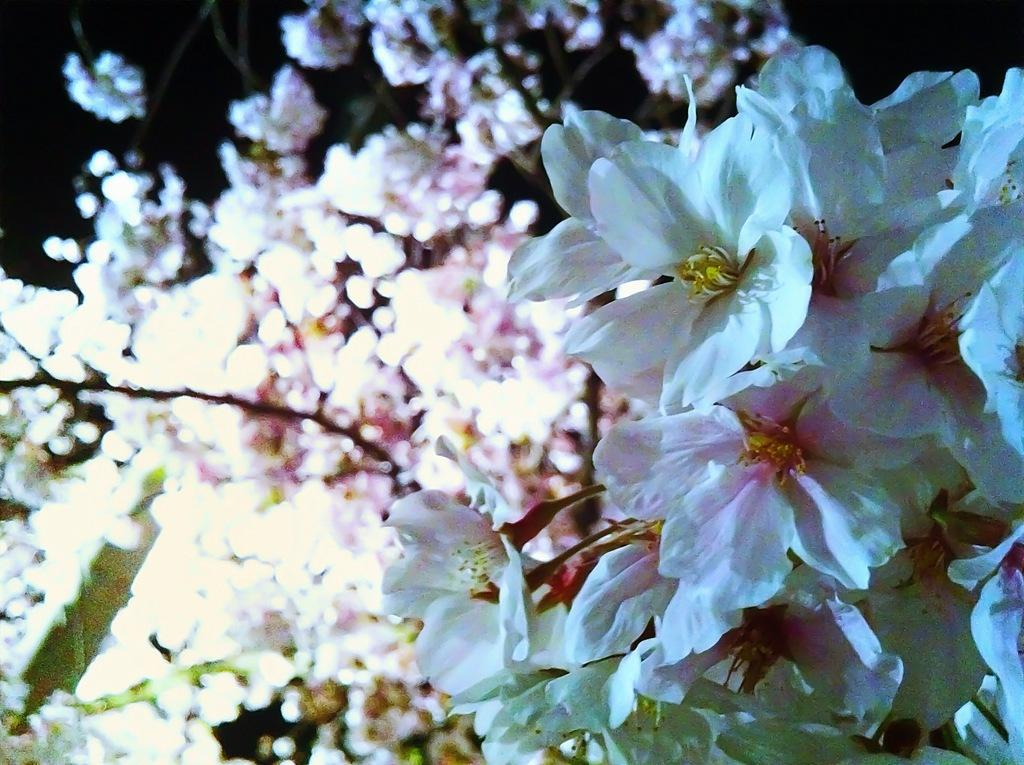What type of living organisms can be seen in the image? Plants can be seen in the image. What specific features do the plants have? The plants have flowers. What color are the flowers? The flowers are white in color. How many clovers are visible in the image? There are no clovers present in the image; it features plants with white flowers. What type of beam is supporting the plants in the image? There is no beam present in the image; the plants are not supported by any visible structure. 